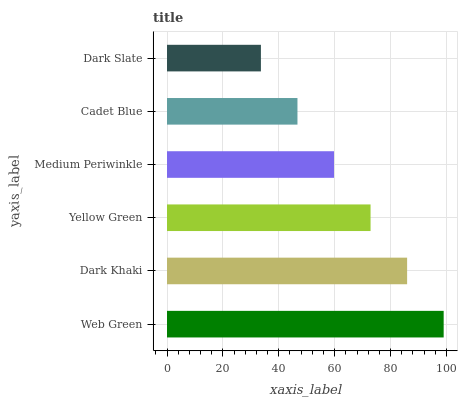Is Dark Slate the minimum?
Answer yes or no. Yes. Is Web Green the maximum?
Answer yes or no. Yes. Is Dark Khaki the minimum?
Answer yes or no. No. Is Dark Khaki the maximum?
Answer yes or no. No. Is Web Green greater than Dark Khaki?
Answer yes or no. Yes. Is Dark Khaki less than Web Green?
Answer yes or no. Yes. Is Dark Khaki greater than Web Green?
Answer yes or no. No. Is Web Green less than Dark Khaki?
Answer yes or no. No. Is Yellow Green the high median?
Answer yes or no. Yes. Is Medium Periwinkle the low median?
Answer yes or no. Yes. Is Cadet Blue the high median?
Answer yes or no. No. Is Dark Khaki the low median?
Answer yes or no. No. 